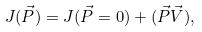Convert formula to latex. <formula><loc_0><loc_0><loc_500><loc_500>J ( \vec { P } ) = J ( \vec { P } = 0 ) + ( \vec { P } \vec { V } ) ,</formula> 